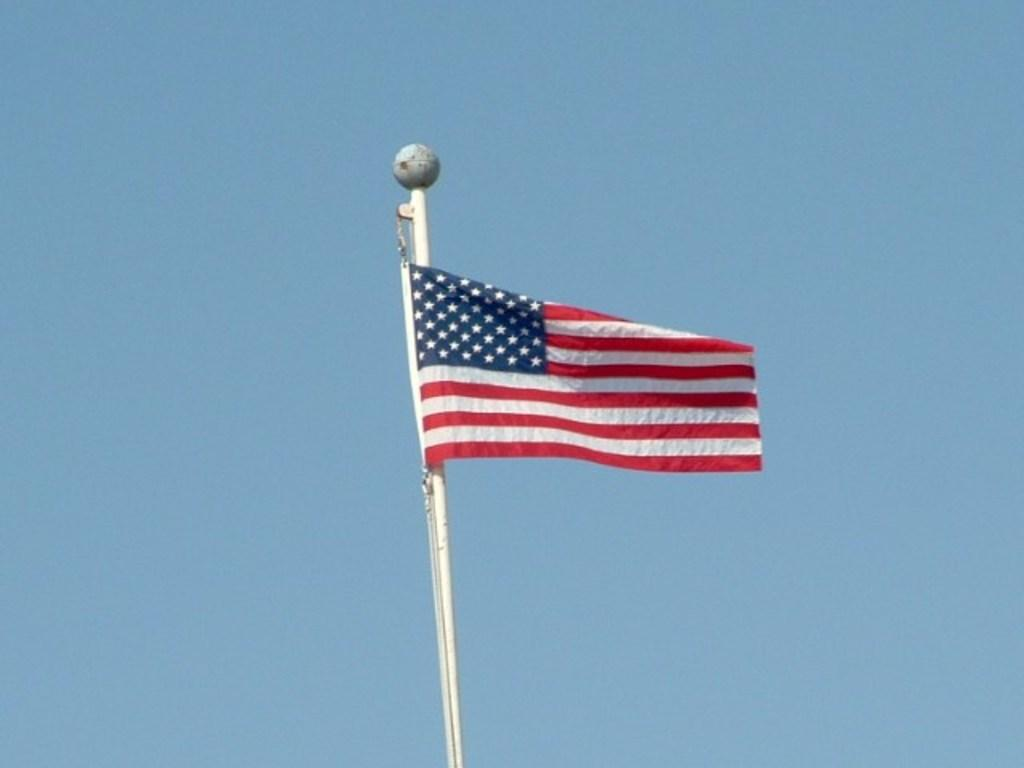What is the main object in the image? There is a flag in the image. What is the flag attached to? The flag is attached to a pole in the image. What color is the background of the image? The background of the image is blue. Where is the scarecrow located in the image? There is no scarecrow present in the image. How many fish can be seen swimming in the background of the image? There are no fish visible in the image, as the background is blue. 